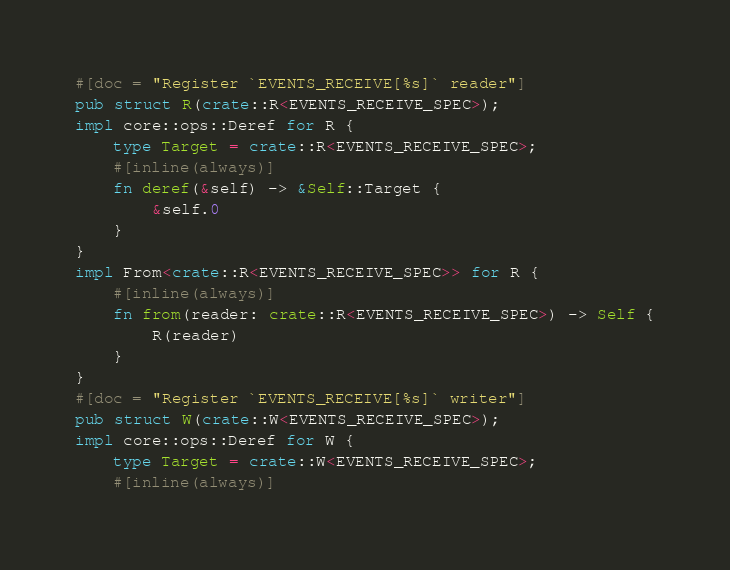Convert code to text. <code><loc_0><loc_0><loc_500><loc_500><_Rust_>#[doc = "Register `EVENTS_RECEIVE[%s]` reader"]
pub struct R(crate::R<EVENTS_RECEIVE_SPEC>);
impl core::ops::Deref for R {
    type Target = crate::R<EVENTS_RECEIVE_SPEC>;
    #[inline(always)]
    fn deref(&self) -> &Self::Target {
        &self.0
    }
}
impl From<crate::R<EVENTS_RECEIVE_SPEC>> for R {
    #[inline(always)]
    fn from(reader: crate::R<EVENTS_RECEIVE_SPEC>) -> Self {
        R(reader)
    }
}
#[doc = "Register `EVENTS_RECEIVE[%s]` writer"]
pub struct W(crate::W<EVENTS_RECEIVE_SPEC>);
impl core::ops::Deref for W {
    type Target = crate::W<EVENTS_RECEIVE_SPEC>;
    #[inline(always)]</code> 